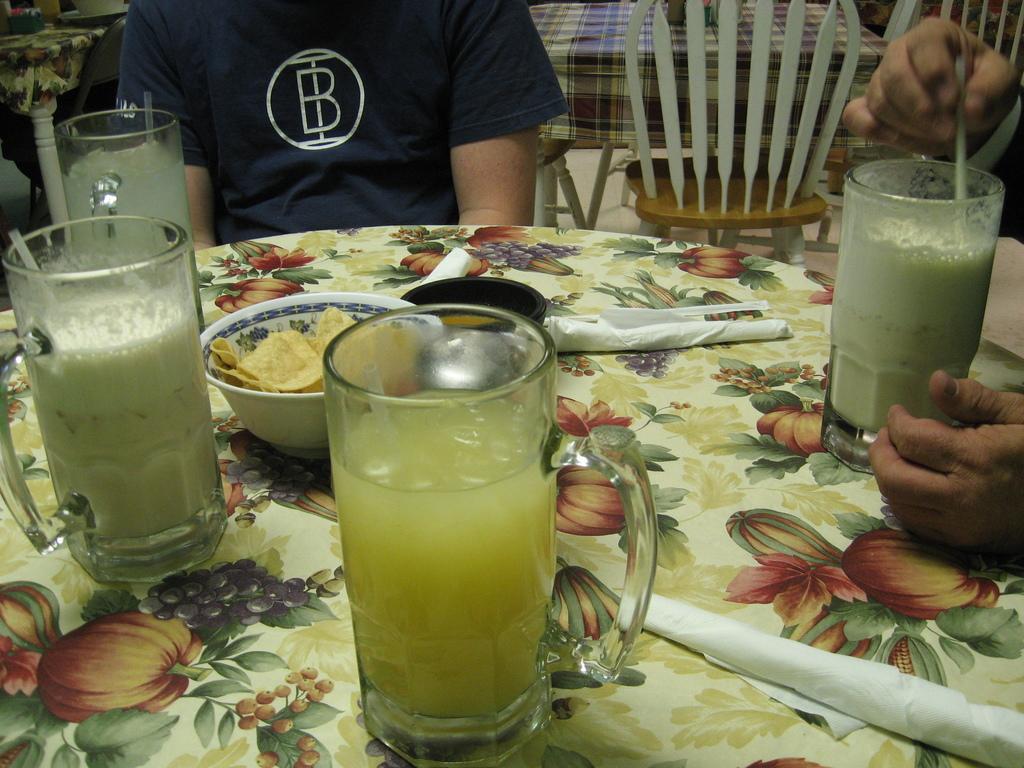In one or two sentences, can you explain what this image depicts? Here on a table we can see a bowl with food item in it,tissue papers,for glasses with liquid in it. In the background there is a person,chairs,objects on tables and on the right we can see a person hands. 